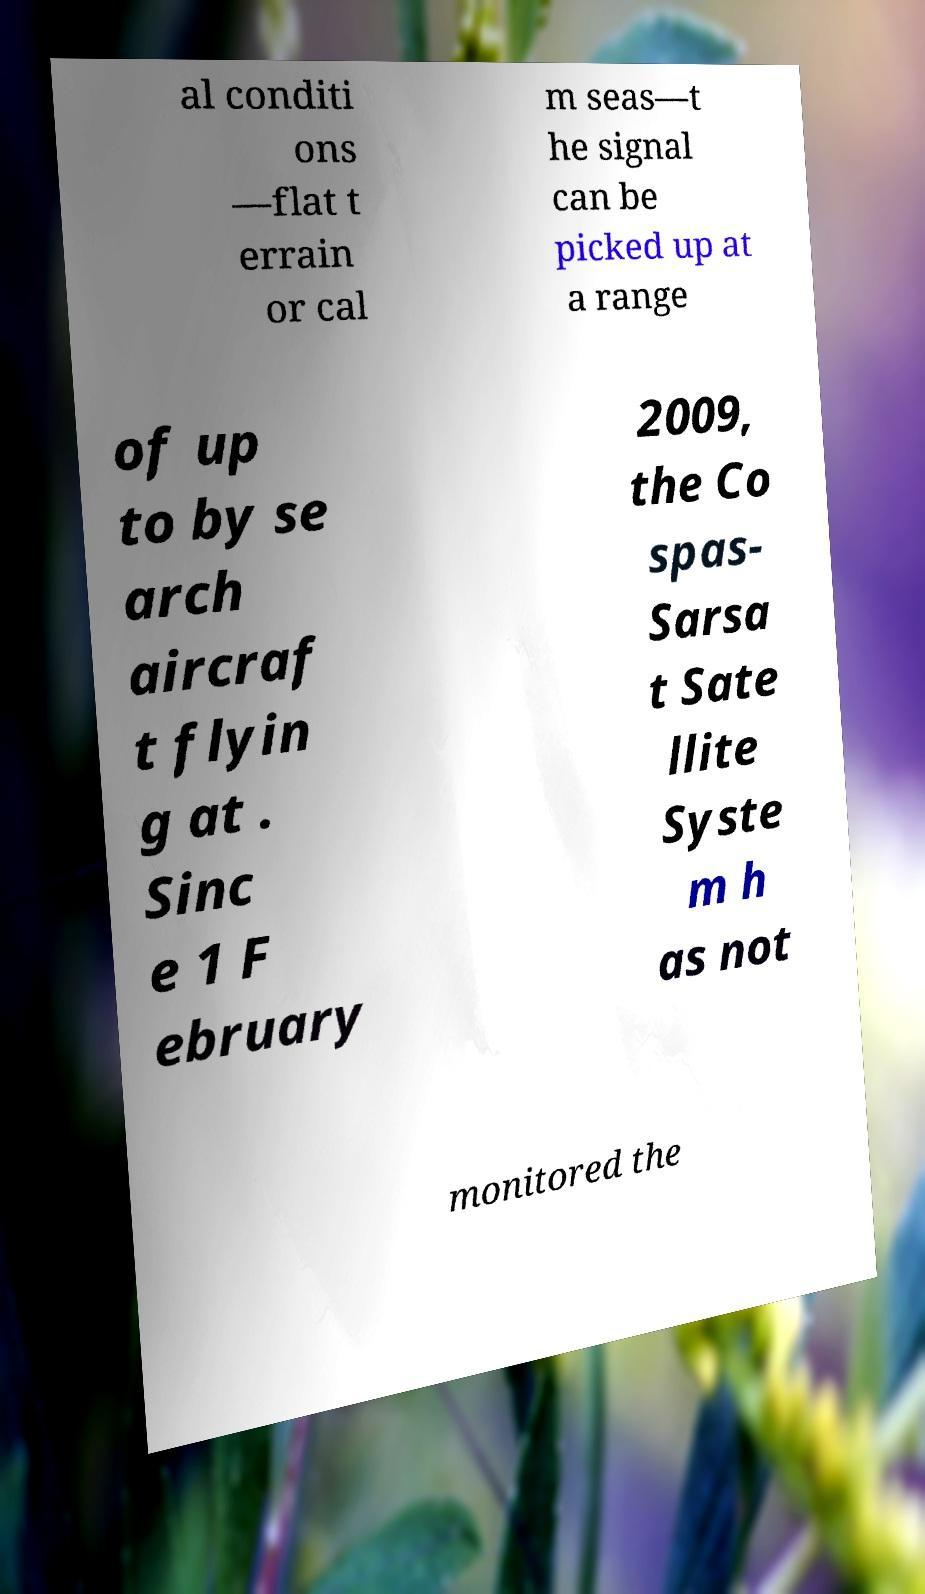Please read and relay the text visible in this image. What does it say? al conditi ons —flat t errain or cal m seas—t he signal can be picked up at a range of up to by se arch aircraf t flyin g at . Sinc e 1 F ebruary 2009, the Co spas- Sarsa t Sate llite Syste m h as not monitored the 